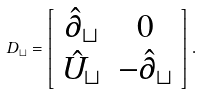Convert formula to latex. <formula><loc_0><loc_0><loc_500><loc_500>D _ { \sqcup } = \left [ \begin{array} { c c } \hat { \partial } _ { \sqcup } & 0 \\ \hat { U } _ { \sqcup } & - \hat { \partial } _ { \sqcup } \end{array} \right ] .</formula> 